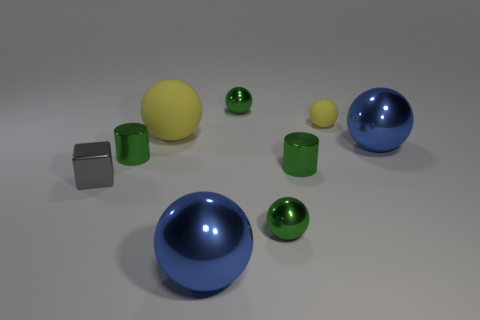How many other objects are there of the same color as the small matte sphere?
Make the answer very short. 1. There is a small object that is the same color as the big rubber ball; what is its material?
Keep it short and to the point. Rubber. How many rubber objects have the same color as the small rubber ball?
Keep it short and to the point. 1. What is the size of the thing that is the same color as the large matte ball?
Make the answer very short. Small. Are there an equal number of tiny matte things to the right of the tiny rubber ball and large yellow matte balls that are behind the small gray block?
Offer a very short reply. No. The metal thing that is left of the large yellow matte ball and on the right side of the gray block has what shape?
Your response must be concise. Cylinder. What number of small green cylinders are in front of the tiny shiny block?
Offer a very short reply. 0. How many other objects are the same shape as the large rubber object?
Keep it short and to the point. 5. Are there fewer big blue spheres than objects?
Keep it short and to the point. Yes. How big is the shiny sphere that is behind the small gray metallic object and in front of the small yellow thing?
Offer a very short reply. Large. 